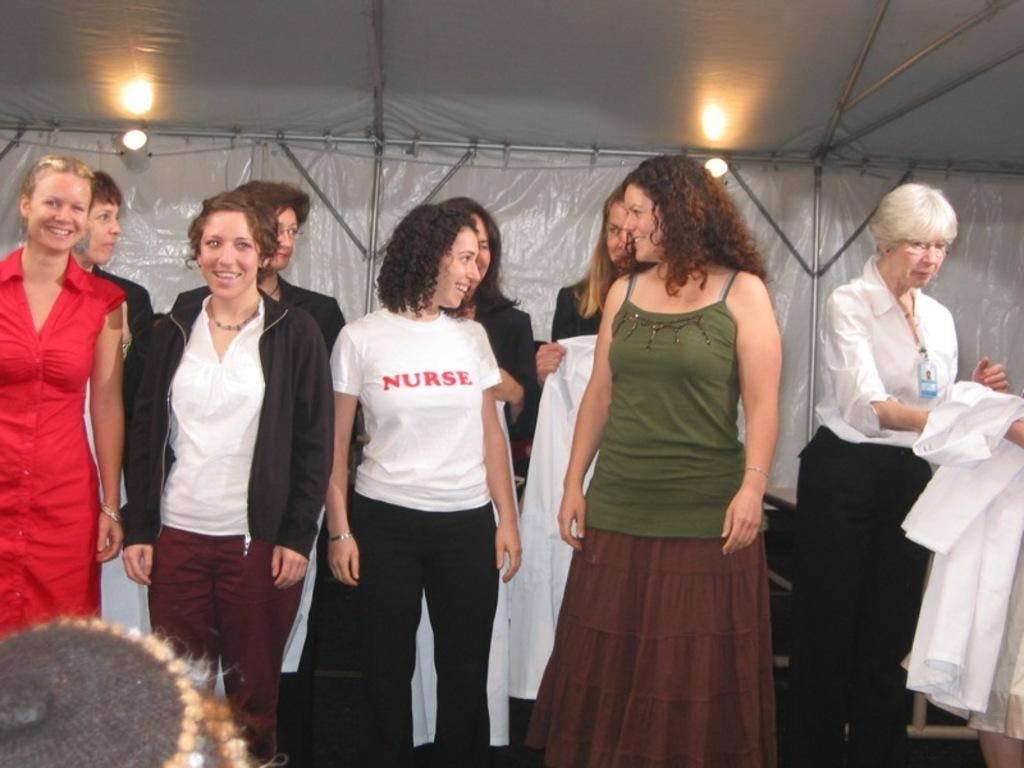What is happening in the image? There are people standing in the image. Can you describe the clothing of the people? The people are wearing different color dresses. What is the person in front holding? The person in front is holding a white cloth. What can be seen in the background of the image? There is a white color cover visible in the background, and lights are present as well. What type of joke is being told by the person holding the whip in the image? There is no person holding a whip in the image, and no joke is being told. How deep is the mine visible in the image? There is no mine present in the image. 